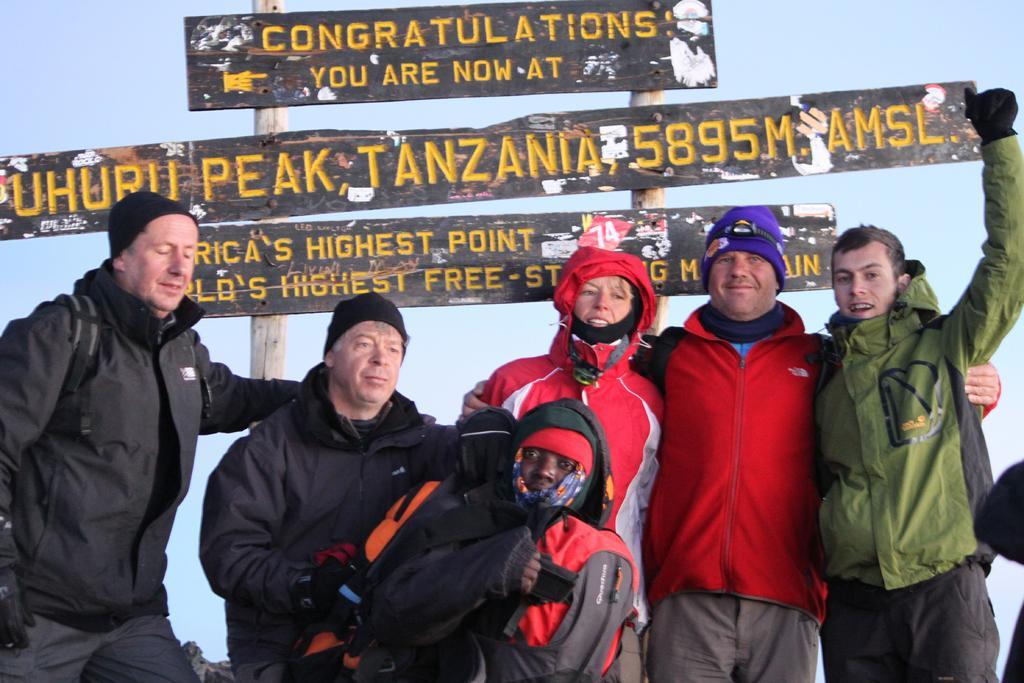Can you describe this image briefly? In this picture I can observe some people wearing jackets and hoodies. Behind these people I can observe black color boards fixed to the wooden poles. I can observe some text on these boards. 